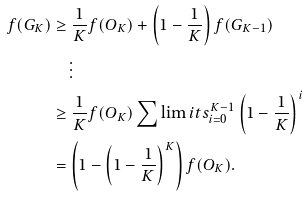Convert formula to latex. <formula><loc_0><loc_0><loc_500><loc_500>f ( G _ { K } ) & \geq \frac { 1 } { K } f ( O _ { K } ) + \left ( 1 - \frac { 1 } { K } \right ) f ( G _ { K - 1 } ) \\ & \quad \vdots \\ & \geq \frac { 1 } { K } f ( O _ { K } ) \sum \lim i t s _ { i = 0 } ^ { K - 1 } \left ( 1 - \frac { 1 } { K } \right ) ^ { i } \\ & = \left ( 1 - \left ( 1 - \frac { 1 } { K } \right ) ^ { K } \right ) f ( O _ { K } ) .</formula> 